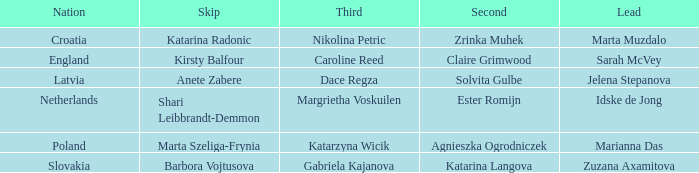In which lead does kirsty balfour hold the second position? Sarah McVey. 